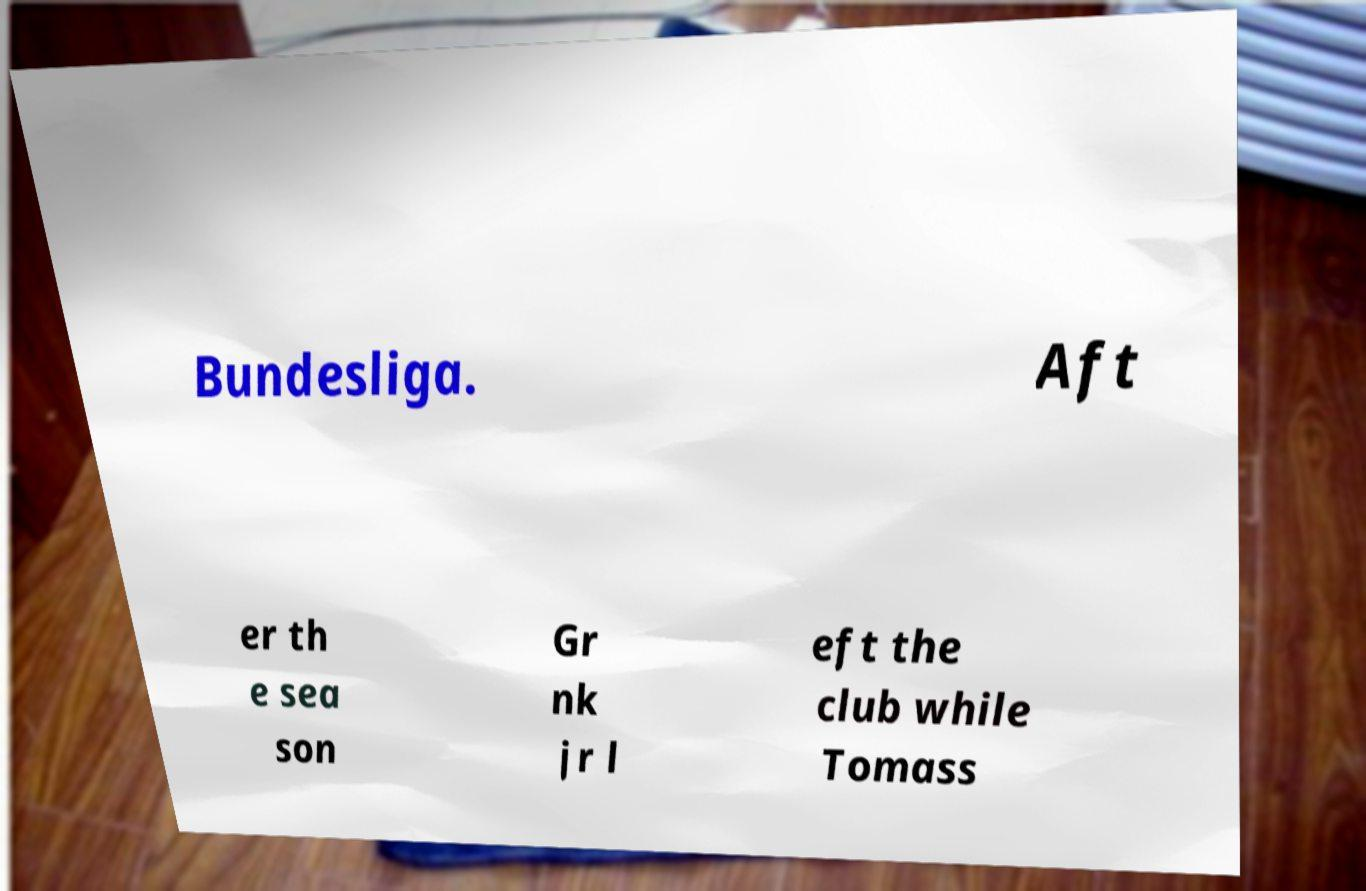Please identify and transcribe the text found in this image. Bundesliga. Aft er th e sea son Gr nk jr l eft the club while Tomass 